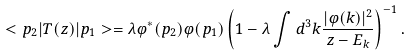<formula> <loc_0><loc_0><loc_500><loc_500>< { p } _ { 2 } | T ( z ) | { p } _ { 1 } > = \lambda \varphi ^ { * } ( { p } _ { 2 } ) \varphi ( { p } _ { 1 } ) \left ( 1 - \lambda \int d ^ { 3 } k \frac { | \varphi ( { k } ) | ^ { 2 } } { z - E _ { k } } \right ) ^ { - 1 } .</formula> 